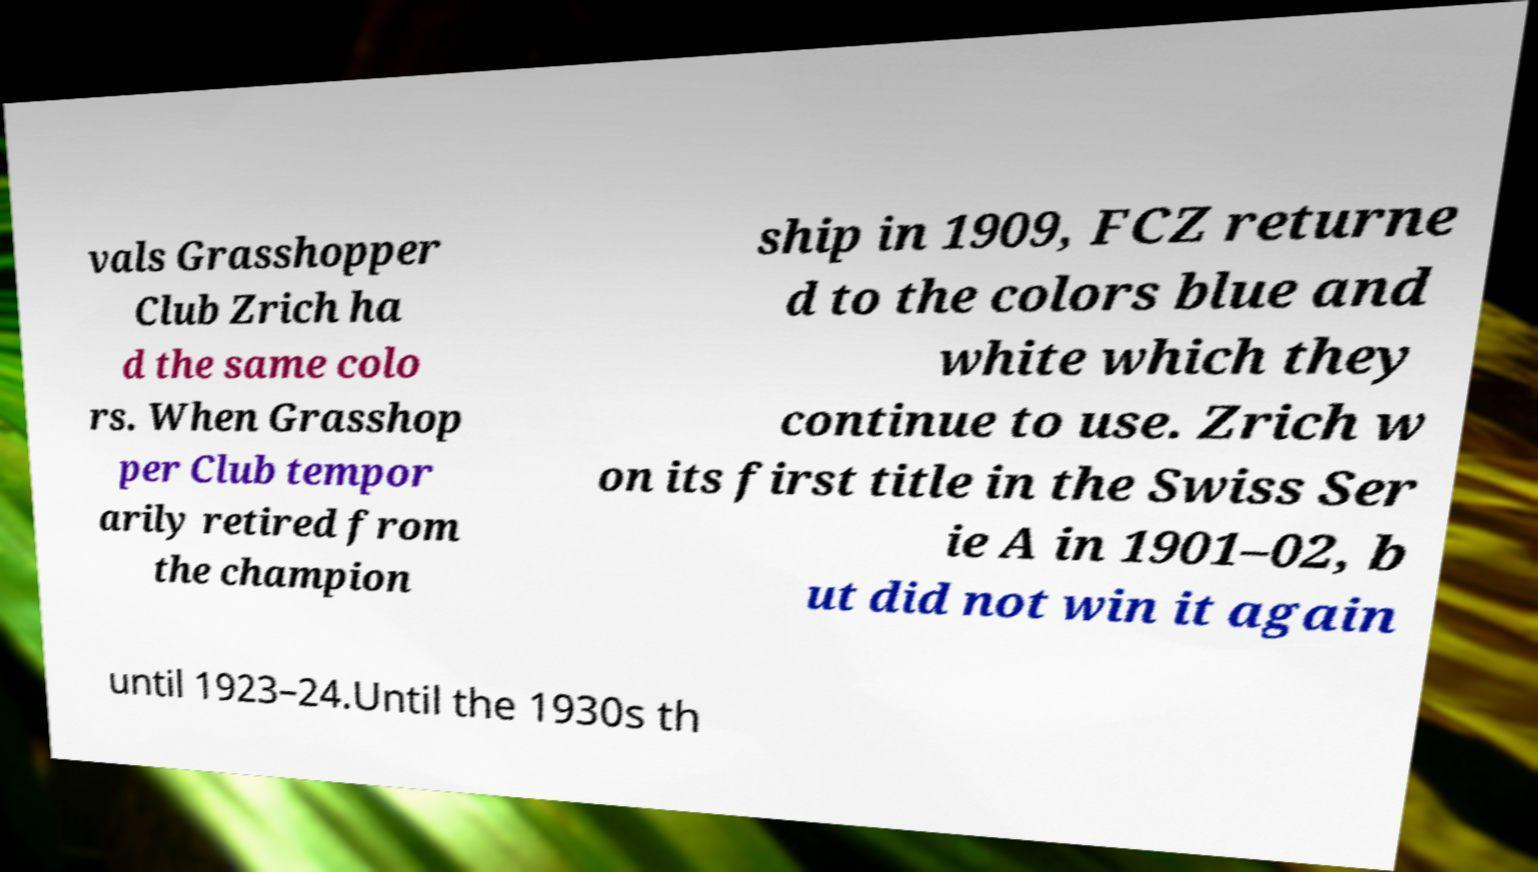Can you accurately transcribe the text from the provided image for me? vals Grasshopper Club Zrich ha d the same colo rs. When Grasshop per Club tempor arily retired from the champion ship in 1909, FCZ returne d to the colors blue and white which they continue to use. Zrich w on its first title in the Swiss Ser ie A in 1901–02, b ut did not win it again until 1923–24.Until the 1930s th 